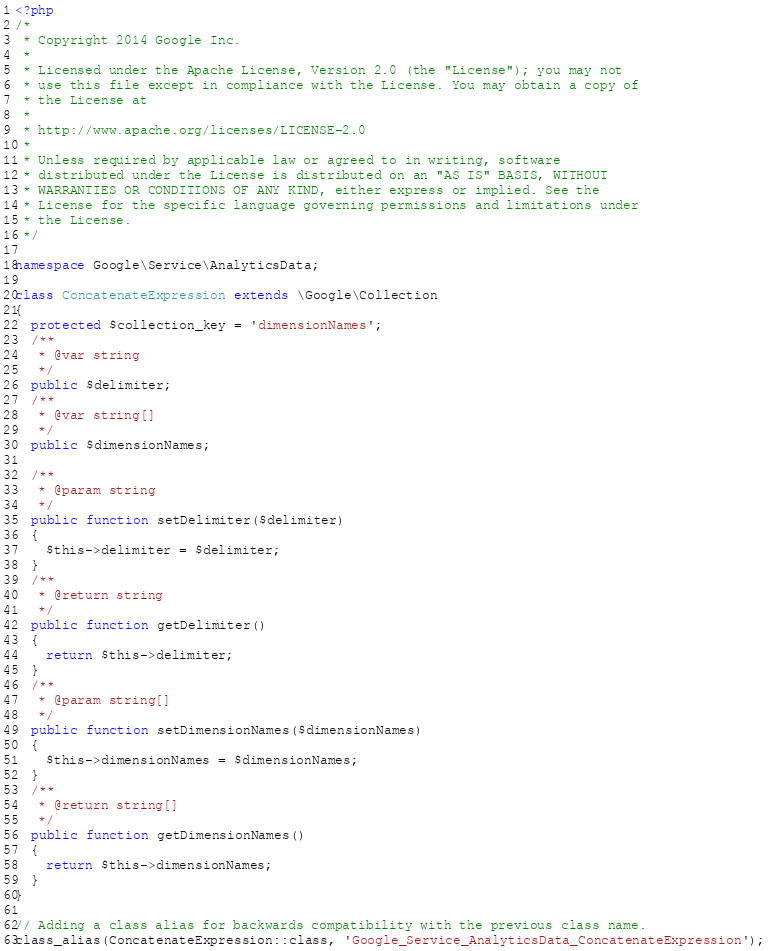Convert code to text. <code><loc_0><loc_0><loc_500><loc_500><_PHP_><?php
/*
 * Copyright 2014 Google Inc.
 *
 * Licensed under the Apache License, Version 2.0 (the "License"); you may not
 * use this file except in compliance with the License. You may obtain a copy of
 * the License at
 *
 * http://www.apache.org/licenses/LICENSE-2.0
 *
 * Unless required by applicable law or agreed to in writing, software
 * distributed under the License is distributed on an "AS IS" BASIS, WITHOUT
 * WARRANTIES OR CONDITIONS OF ANY KIND, either express or implied. See the
 * License for the specific language governing permissions and limitations under
 * the License.
 */

namespace Google\Service\AnalyticsData;

class ConcatenateExpression extends \Google\Collection
{
  protected $collection_key = 'dimensionNames';
  /**
   * @var string
   */
  public $delimiter;
  /**
   * @var string[]
   */
  public $dimensionNames;

  /**
   * @param string
   */
  public function setDelimiter($delimiter)
  {
    $this->delimiter = $delimiter;
  }
  /**
   * @return string
   */
  public function getDelimiter()
  {
    return $this->delimiter;
  }
  /**
   * @param string[]
   */
  public function setDimensionNames($dimensionNames)
  {
    $this->dimensionNames = $dimensionNames;
  }
  /**
   * @return string[]
   */
  public function getDimensionNames()
  {
    return $this->dimensionNames;
  }
}

// Adding a class alias for backwards compatibility with the previous class name.
class_alias(ConcatenateExpression::class, 'Google_Service_AnalyticsData_ConcatenateExpression');
</code> 